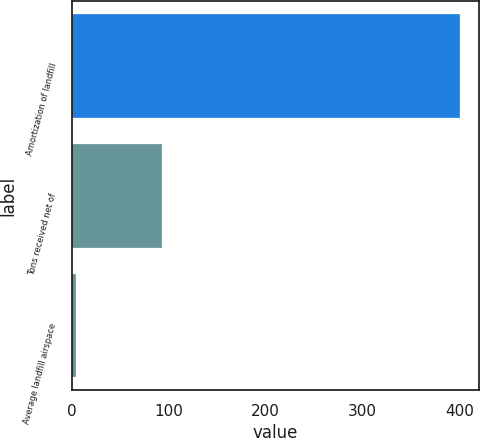Convert chart. <chart><loc_0><loc_0><loc_500><loc_500><bar_chart><fcel>Amortization of landfill<fcel>Tons received net of<fcel>Average landfill airspace<nl><fcel>400<fcel>93<fcel>4.29<nl></chart> 